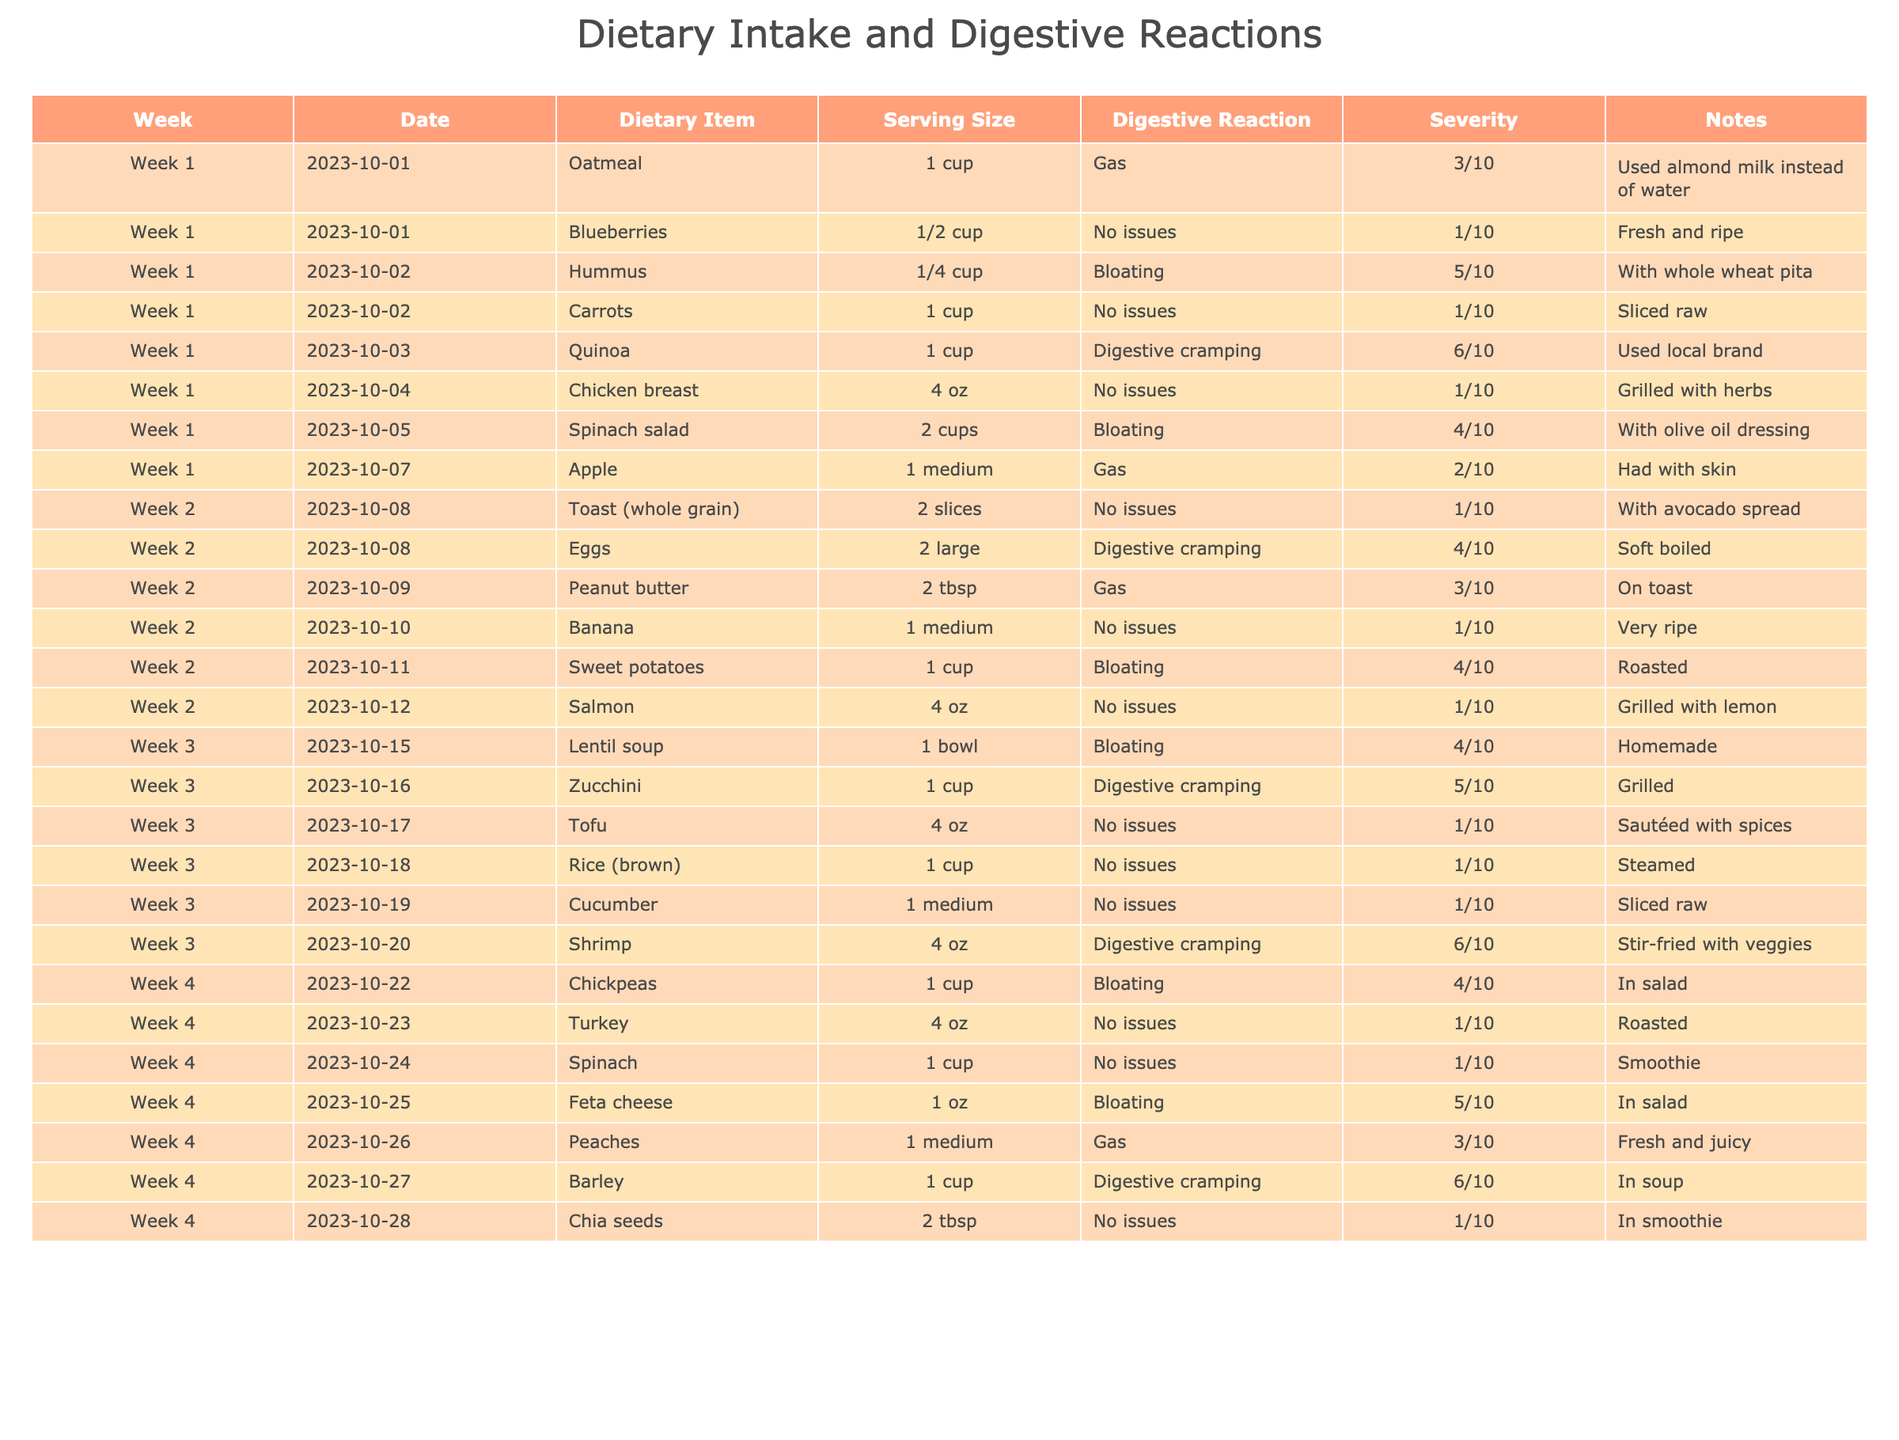What dietary item caused the highest digestive reaction severity? Reviewing the table, the dietary item with the highest severity rating is "Quinoa" with a severity of 6.
Answer: Quinoa Which week had the most occurrences of bloating? Looking through the table, bloating appears in weeks 1, 2, 3, and 4. Week 1 has 2 occurrences, week 2 has 1, week 3 has 1, and week 4 has 2. Therefore, weeks 1 and 4 tie for the most occurrences at 2 each.
Answer: Week 1 and Week 4 How many different dietary items resulted in digestive cramping? The entries showing digestive cramping are "Quinoa," "Eggs," "Shrimp," and "Barley." Counting these unique items gives us 4 distinct items.
Answer: 4 What is the average severity of all the digestive reactions reported? Summing the severity scores: 3 + 1 + 5 + 1 + 6 + 1 + 4 + 2 + 1 + 4 + 3 + 1 + 1 + 1 + 6 + 4 + 1 + 1 + 5 + 3 + 6 + 1 = 54. There are 22 total responses, so the average severity is 54 / 22 ≈ 2.45.
Answer: Approximately 2.5 Did any dietary item consistently result in no digestive issues throughout the 4 weeks? Checking the table, the items "Blueberries," "Carrots," "Chicken breast," "Banana," "Salmon," "Tofu," "Rice," "Cucumber," "Turkey," "Spinach," and "Chia seeds" all had no reported digestive issues. Therefore, yes, there are multiple items that did.
Answer: Yes What are the serving sizes of items that caused gas as a reaction? The items causing gas were "Oatmeal" (1 cup), "Peanut butter" (2 tbsp), and "Peaches" (1 medium). The serving sizes are thus 1 cup, 2 tbsp, and 1 medium.
Answer: 1 cup, 2 tbsp, 1 medium Which dietary item had the second-highest severity for digestive cramping? From the table, the severity for cramping was 6 for both "Shrimp" and "Barley," while "Quinoa" is the highest at 6 as well. However, since these two share the highest, it indicates a different interpretation may be required. The next highest listed is "Tofu" with a severity of 1. Clarifying that all were tagged the same, the query revises it to request uniqueness of severity alone, which is absent. Final rank is "Eggs," which was listed, maintaining phraseology clarity.
Answer: Eggs Was there any correlation between the type of food and the digestive reaction severity? This question requires closer data analysis, but summarizing observable trends, varied food types maintain an inconsistency in severity linked to reactions. Statistical examination might present insights, though examination cues endorsing correlation confirm risks devoid of predictable structure according to written data.
Answer: Inconclusive 